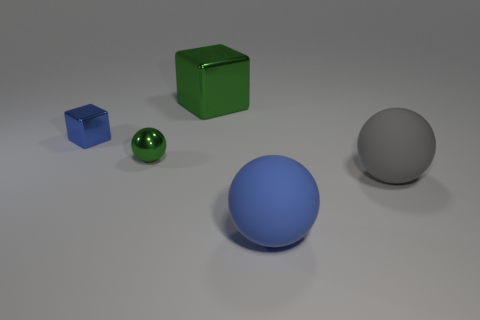Subtract all matte spheres. How many spheres are left? 1 Add 2 big green shiny things. How many objects exist? 7 Subtract all balls. How many objects are left? 2 Add 4 large gray matte balls. How many large gray matte balls exist? 5 Subtract 1 green cubes. How many objects are left? 4 Subtract all small blue metallic objects. Subtract all big rubber objects. How many objects are left? 2 Add 1 blue things. How many blue things are left? 3 